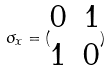Convert formula to latex. <formula><loc_0><loc_0><loc_500><loc_500>\sigma _ { x } = ( \begin{matrix} 0 & 1 \\ 1 & 0 \end{matrix} )</formula> 